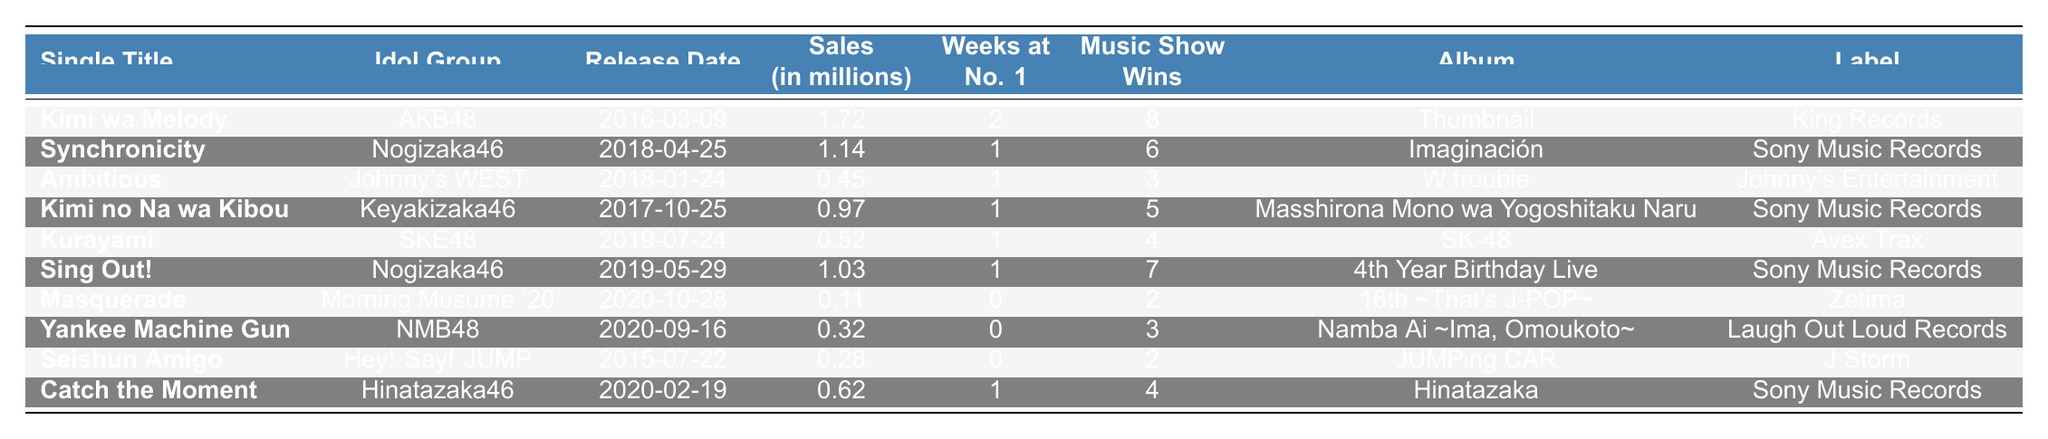What is the title of the single with the highest sales? The single with the highest sales is "Kimi wa Melody" by AKB48, which has sales of 1.72 million.
Answer: Kimi wa Melody How many weeks did "Sing Out!" by Nogizaka46 stay at No. 1? "Sing Out!" peaked at No. 1 for 1 week according to the table.
Answer: 1 Which idol group had a single released on "2018-04-25"? The idol group that had a single released on "2018-04-25" is Nogizaka46, with the single "Synchronicity".
Answer: Nogizaka46 What is the total sales in millions for singles released by SKE48? SKE48 has only one single listed, "Kurayami," with sales of 0.52 million. Therefore, total sales are 0.52 million.
Answer: 0.52 million Did "Seishun Amigo" by Hey! Say! JUMP achieve any music show wins? Yes, "Seishun Amigo" achieved 2 music show wins as mentioned in the table.
Answer: Yes Which album was "Kimi no Na wa Kibou" by Keyakizaka46 associated with? "Kimi no Na wa Kibou" is associated with the album "Masshirona Mono wa Yogoshitaku Naru".
Answer: Masshirona Mono wa Yogoshitaku Naru What is the average sales of all singles listed in the table? To find the average, sum the sales: 1.72 + 1.14 + 0.45 + 0.97 + 0.52 + 1.03 + 0.11 + 0.32 + 0.28 + 0.62 = 6.20 million. There are 10 singles, so average sales = 6.20 / 10 = 0.62 million.
Answer: 0.62 million How many singles had more than 2 music show wins? Only "Kimi wa Melody" by AKB48 had 8 music show wins. No other single had more than 2 wins.
Answer: 1 Which idol group has the single "Masquerade"? The single "Masquerade" belongs to Morning Musume '20.
Answer: Morning Musume '20 Is there a single by Johnny's WEST that had zero weeks at No. 1? Yes, the single "Ambitious" by Johnny's WEST had 1 week at No. 1; hence it does not have zero weeks.
Answer: No 